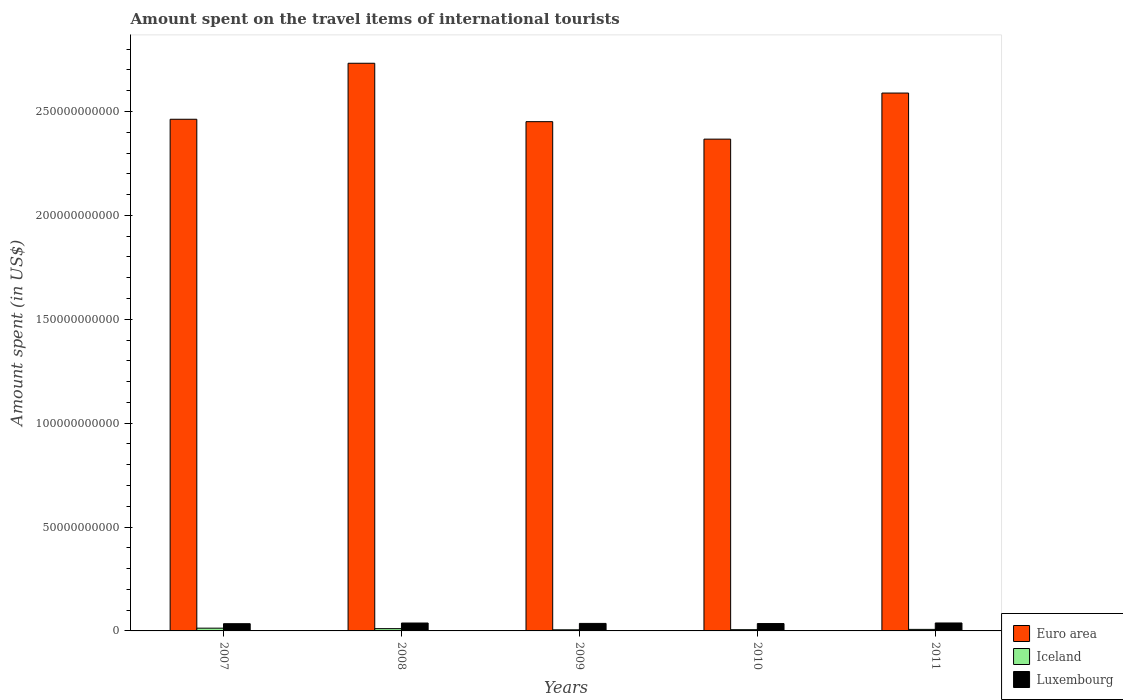How many groups of bars are there?
Your answer should be very brief. 5. Are the number of bars per tick equal to the number of legend labels?
Your answer should be compact. Yes. How many bars are there on the 1st tick from the left?
Your answer should be very brief. 3. How many bars are there on the 5th tick from the right?
Ensure brevity in your answer.  3. What is the label of the 5th group of bars from the left?
Your answer should be very brief. 2011. What is the amount spent on the travel items of international tourists in Iceland in 2008?
Your answer should be compact. 1.10e+09. Across all years, what is the maximum amount spent on the travel items of international tourists in Luxembourg?
Make the answer very short. 3.82e+09. Across all years, what is the minimum amount spent on the travel items of international tourists in Euro area?
Give a very brief answer. 2.37e+11. In which year was the amount spent on the travel items of international tourists in Luxembourg minimum?
Offer a terse response. 2007. What is the total amount spent on the travel items of international tourists in Luxembourg in the graph?
Make the answer very short. 1.83e+1. What is the difference between the amount spent on the travel items of international tourists in Iceland in 2009 and that in 2011?
Ensure brevity in your answer.  -2.06e+08. What is the difference between the amount spent on the travel items of international tourists in Euro area in 2007 and the amount spent on the travel items of international tourists in Iceland in 2009?
Make the answer very short. 2.46e+11. What is the average amount spent on the travel items of international tourists in Luxembourg per year?
Offer a very short reply. 3.65e+09. In the year 2010, what is the difference between the amount spent on the travel items of international tourists in Luxembourg and amount spent on the travel items of international tourists in Iceland?
Keep it short and to the point. 2.95e+09. What is the ratio of the amount spent on the travel items of international tourists in Iceland in 2008 to that in 2011?
Keep it short and to the point. 1.49. What is the difference between the highest and the second highest amount spent on the travel items of international tourists in Iceland?
Keep it short and to the point. 2.23e+08. What is the difference between the highest and the lowest amount spent on the travel items of international tourists in Iceland?
Provide a succinct answer. 7.92e+08. Is the sum of the amount spent on the travel items of international tourists in Iceland in 2007 and 2008 greater than the maximum amount spent on the travel items of international tourists in Luxembourg across all years?
Your answer should be compact. No. What does the 2nd bar from the right in 2010 represents?
Your response must be concise. Iceland. How many bars are there?
Provide a short and direct response. 15. Are all the bars in the graph horizontal?
Your answer should be very brief. No. What is the difference between two consecutive major ticks on the Y-axis?
Keep it short and to the point. 5.00e+1. Are the values on the major ticks of Y-axis written in scientific E-notation?
Keep it short and to the point. No. Where does the legend appear in the graph?
Give a very brief answer. Bottom right. How many legend labels are there?
Ensure brevity in your answer.  3. How are the legend labels stacked?
Make the answer very short. Vertical. What is the title of the graph?
Ensure brevity in your answer.  Amount spent on the travel items of international tourists. Does "Australia" appear as one of the legend labels in the graph?
Make the answer very short. No. What is the label or title of the X-axis?
Ensure brevity in your answer.  Years. What is the label or title of the Y-axis?
Keep it short and to the point. Amount spent (in US$). What is the Amount spent (in US$) in Euro area in 2007?
Offer a very short reply. 2.46e+11. What is the Amount spent (in US$) of Iceland in 2007?
Keep it short and to the point. 1.33e+09. What is the Amount spent (in US$) in Luxembourg in 2007?
Give a very brief answer. 3.48e+09. What is the Amount spent (in US$) of Euro area in 2008?
Ensure brevity in your answer.  2.73e+11. What is the Amount spent (in US$) of Iceland in 2008?
Ensure brevity in your answer.  1.10e+09. What is the Amount spent (in US$) of Luxembourg in 2008?
Your response must be concise. 3.80e+09. What is the Amount spent (in US$) in Euro area in 2009?
Offer a very short reply. 2.45e+11. What is the Amount spent (in US$) of Iceland in 2009?
Your answer should be compact. 5.34e+08. What is the Amount spent (in US$) of Luxembourg in 2009?
Make the answer very short. 3.61e+09. What is the Amount spent (in US$) in Euro area in 2010?
Your response must be concise. 2.37e+11. What is the Amount spent (in US$) in Iceland in 2010?
Your answer should be compact. 5.99e+08. What is the Amount spent (in US$) in Luxembourg in 2010?
Ensure brevity in your answer.  3.55e+09. What is the Amount spent (in US$) in Euro area in 2011?
Make the answer very short. 2.59e+11. What is the Amount spent (in US$) of Iceland in 2011?
Make the answer very short. 7.40e+08. What is the Amount spent (in US$) in Luxembourg in 2011?
Your answer should be compact. 3.82e+09. Across all years, what is the maximum Amount spent (in US$) in Euro area?
Provide a succinct answer. 2.73e+11. Across all years, what is the maximum Amount spent (in US$) of Iceland?
Keep it short and to the point. 1.33e+09. Across all years, what is the maximum Amount spent (in US$) of Luxembourg?
Your response must be concise. 3.82e+09. Across all years, what is the minimum Amount spent (in US$) of Euro area?
Make the answer very short. 2.37e+11. Across all years, what is the minimum Amount spent (in US$) of Iceland?
Your answer should be very brief. 5.34e+08. Across all years, what is the minimum Amount spent (in US$) in Luxembourg?
Offer a very short reply. 3.48e+09. What is the total Amount spent (in US$) of Euro area in the graph?
Offer a terse response. 1.26e+12. What is the total Amount spent (in US$) in Iceland in the graph?
Give a very brief answer. 4.30e+09. What is the total Amount spent (in US$) in Luxembourg in the graph?
Keep it short and to the point. 1.83e+1. What is the difference between the Amount spent (in US$) in Euro area in 2007 and that in 2008?
Make the answer very short. -2.70e+1. What is the difference between the Amount spent (in US$) in Iceland in 2007 and that in 2008?
Your answer should be compact. 2.23e+08. What is the difference between the Amount spent (in US$) in Luxembourg in 2007 and that in 2008?
Your answer should be very brief. -3.25e+08. What is the difference between the Amount spent (in US$) in Euro area in 2007 and that in 2009?
Offer a very short reply. 1.16e+09. What is the difference between the Amount spent (in US$) of Iceland in 2007 and that in 2009?
Offer a very short reply. 7.92e+08. What is the difference between the Amount spent (in US$) in Luxembourg in 2007 and that in 2009?
Make the answer very short. -1.36e+08. What is the difference between the Amount spent (in US$) of Euro area in 2007 and that in 2010?
Keep it short and to the point. 9.57e+09. What is the difference between the Amount spent (in US$) of Iceland in 2007 and that in 2010?
Your answer should be very brief. 7.27e+08. What is the difference between the Amount spent (in US$) of Luxembourg in 2007 and that in 2010?
Offer a very short reply. -7.30e+07. What is the difference between the Amount spent (in US$) in Euro area in 2007 and that in 2011?
Ensure brevity in your answer.  -1.26e+1. What is the difference between the Amount spent (in US$) in Iceland in 2007 and that in 2011?
Provide a succinct answer. 5.86e+08. What is the difference between the Amount spent (in US$) in Luxembourg in 2007 and that in 2011?
Keep it short and to the point. -3.46e+08. What is the difference between the Amount spent (in US$) in Euro area in 2008 and that in 2009?
Provide a succinct answer. 2.81e+1. What is the difference between the Amount spent (in US$) of Iceland in 2008 and that in 2009?
Provide a short and direct response. 5.69e+08. What is the difference between the Amount spent (in US$) of Luxembourg in 2008 and that in 2009?
Offer a terse response. 1.89e+08. What is the difference between the Amount spent (in US$) of Euro area in 2008 and that in 2010?
Ensure brevity in your answer.  3.65e+1. What is the difference between the Amount spent (in US$) in Iceland in 2008 and that in 2010?
Provide a short and direct response. 5.04e+08. What is the difference between the Amount spent (in US$) of Luxembourg in 2008 and that in 2010?
Make the answer very short. 2.52e+08. What is the difference between the Amount spent (in US$) of Euro area in 2008 and that in 2011?
Ensure brevity in your answer.  1.43e+1. What is the difference between the Amount spent (in US$) in Iceland in 2008 and that in 2011?
Offer a very short reply. 3.63e+08. What is the difference between the Amount spent (in US$) of Luxembourg in 2008 and that in 2011?
Offer a terse response. -2.10e+07. What is the difference between the Amount spent (in US$) in Euro area in 2009 and that in 2010?
Offer a terse response. 8.41e+09. What is the difference between the Amount spent (in US$) of Iceland in 2009 and that in 2010?
Provide a succinct answer. -6.50e+07. What is the difference between the Amount spent (in US$) in Luxembourg in 2009 and that in 2010?
Provide a short and direct response. 6.30e+07. What is the difference between the Amount spent (in US$) in Euro area in 2009 and that in 2011?
Provide a short and direct response. -1.38e+1. What is the difference between the Amount spent (in US$) in Iceland in 2009 and that in 2011?
Provide a succinct answer. -2.06e+08. What is the difference between the Amount spent (in US$) in Luxembourg in 2009 and that in 2011?
Provide a short and direct response. -2.10e+08. What is the difference between the Amount spent (in US$) in Euro area in 2010 and that in 2011?
Provide a short and direct response. -2.22e+1. What is the difference between the Amount spent (in US$) of Iceland in 2010 and that in 2011?
Your response must be concise. -1.41e+08. What is the difference between the Amount spent (in US$) of Luxembourg in 2010 and that in 2011?
Offer a very short reply. -2.73e+08. What is the difference between the Amount spent (in US$) of Euro area in 2007 and the Amount spent (in US$) of Iceland in 2008?
Keep it short and to the point. 2.45e+11. What is the difference between the Amount spent (in US$) of Euro area in 2007 and the Amount spent (in US$) of Luxembourg in 2008?
Keep it short and to the point. 2.42e+11. What is the difference between the Amount spent (in US$) of Iceland in 2007 and the Amount spent (in US$) of Luxembourg in 2008?
Your answer should be very brief. -2.48e+09. What is the difference between the Amount spent (in US$) of Euro area in 2007 and the Amount spent (in US$) of Iceland in 2009?
Your response must be concise. 2.46e+11. What is the difference between the Amount spent (in US$) in Euro area in 2007 and the Amount spent (in US$) in Luxembourg in 2009?
Provide a short and direct response. 2.43e+11. What is the difference between the Amount spent (in US$) in Iceland in 2007 and the Amount spent (in US$) in Luxembourg in 2009?
Ensure brevity in your answer.  -2.29e+09. What is the difference between the Amount spent (in US$) of Euro area in 2007 and the Amount spent (in US$) of Iceland in 2010?
Offer a very short reply. 2.46e+11. What is the difference between the Amount spent (in US$) of Euro area in 2007 and the Amount spent (in US$) of Luxembourg in 2010?
Provide a succinct answer. 2.43e+11. What is the difference between the Amount spent (in US$) of Iceland in 2007 and the Amount spent (in US$) of Luxembourg in 2010?
Ensure brevity in your answer.  -2.22e+09. What is the difference between the Amount spent (in US$) in Euro area in 2007 and the Amount spent (in US$) in Iceland in 2011?
Provide a succinct answer. 2.46e+11. What is the difference between the Amount spent (in US$) in Euro area in 2007 and the Amount spent (in US$) in Luxembourg in 2011?
Ensure brevity in your answer.  2.42e+11. What is the difference between the Amount spent (in US$) in Iceland in 2007 and the Amount spent (in US$) in Luxembourg in 2011?
Offer a very short reply. -2.50e+09. What is the difference between the Amount spent (in US$) of Euro area in 2008 and the Amount spent (in US$) of Iceland in 2009?
Your answer should be very brief. 2.73e+11. What is the difference between the Amount spent (in US$) in Euro area in 2008 and the Amount spent (in US$) in Luxembourg in 2009?
Your response must be concise. 2.70e+11. What is the difference between the Amount spent (in US$) of Iceland in 2008 and the Amount spent (in US$) of Luxembourg in 2009?
Provide a succinct answer. -2.51e+09. What is the difference between the Amount spent (in US$) of Euro area in 2008 and the Amount spent (in US$) of Iceland in 2010?
Provide a succinct answer. 2.73e+11. What is the difference between the Amount spent (in US$) in Euro area in 2008 and the Amount spent (in US$) in Luxembourg in 2010?
Make the answer very short. 2.70e+11. What is the difference between the Amount spent (in US$) of Iceland in 2008 and the Amount spent (in US$) of Luxembourg in 2010?
Give a very brief answer. -2.45e+09. What is the difference between the Amount spent (in US$) in Euro area in 2008 and the Amount spent (in US$) in Iceland in 2011?
Offer a very short reply. 2.72e+11. What is the difference between the Amount spent (in US$) of Euro area in 2008 and the Amount spent (in US$) of Luxembourg in 2011?
Make the answer very short. 2.69e+11. What is the difference between the Amount spent (in US$) in Iceland in 2008 and the Amount spent (in US$) in Luxembourg in 2011?
Offer a terse response. -2.72e+09. What is the difference between the Amount spent (in US$) of Euro area in 2009 and the Amount spent (in US$) of Iceland in 2010?
Offer a very short reply. 2.45e+11. What is the difference between the Amount spent (in US$) in Euro area in 2009 and the Amount spent (in US$) in Luxembourg in 2010?
Offer a terse response. 2.42e+11. What is the difference between the Amount spent (in US$) in Iceland in 2009 and the Amount spent (in US$) in Luxembourg in 2010?
Provide a short and direct response. -3.02e+09. What is the difference between the Amount spent (in US$) in Euro area in 2009 and the Amount spent (in US$) in Iceland in 2011?
Provide a succinct answer. 2.44e+11. What is the difference between the Amount spent (in US$) in Euro area in 2009 and the Amount spent (in US$) in Luxembourg in 2011?
Ensure brevity in your answer.  2.41e+11. What is the difference between the Amount spent (in US$) of Iceland in 2009 and the Amount spent (in US$) of Luxembourg in 2011?
Your answer should be compact. -3.29e+09. What is the difference between the Amount spent (in US$) in Euro area in 2010 and the Amount spent (in US$) in Iceland in 2011?
Keep it short and to the point. 2.36e+11. What is the difference between the Amount spent (in US$) of Euro area in 2010 and the Amount spent (in US$) of Luxembourg in 2011?
Ensure brevity in your answer.  2.33e+11. What is the difference between the Amount spent (in US$) in Iceland in 2010 and the Amount spent (in US$) in Luxembourg in 2011?
Offer a very short reply. -3.22e+09. What is the average Amount spent (in US$) in Euro area per year?
Keep it short and to the point. 2.52e+11. What is the average Amount spent (in US$) in Iceland per year?
Offer a terse response. 8.60e+08. What is the average Amount spent (in US$) in Luxembourg per year?
Offer a very short reply. 3.65e+09. In the year 2007, what is the difference between the Amount spent (in US$) in Euro area and Amount spent (in US$) in Iceland?
Provide a short and direct response. 2.45e+11. In the year 2007, what is the difference between the Amount spent (in US$) in Euro area and Amount spent (in US$) in Luxembourg?
Your answer should be very brief. 2.43e+11. In the year 2007, what is the difference between the Amount spent (in US$) in Iceland and Amount spent (in US$) in Luxembourg?
Ensure brevity in your answer.  -2.15e+09. In the year 2008, what is the difference between the Amount spent (in US$) in Euro area and Amount spent (in US$) in Iceland?
Provide a short and direct response. 2.72e+11. In the year 2008, what is the difference between the Amount spent (in US$) of Euro area and Amount spent (in US$) of Luxembourg?
Ensure brevity in your answer.  2.69e+11. In the year 2008, what is the difference between the Amount spent (in US$) in Iceland and Amount spent (in US$) in Luxembourg?
Your answer should be compact. -2.70e+09. In the year 2009, what is the difference between the Amount spent (in US$) of Euro area and Amount spent (in US$) of Iceland?
Your answer should be very brief. 2.45e+11. In the year 2009, what is the difference between the Amount spent (in US$) of Euro area and Amount spent (in US$) of Luxembourg?
Make the answer very short. 2.41e+11. In the year 2009, what is the difference between the Amount spent (in US$) in Iceland and Amount spent (in US$) in Luxembourg?
Provide a short and direct response. -3.08e+09. In the year 2010, what is the difference between the Amount spent (in US$) in Euro area and Amount spent (in US$) in Iceland?
Give a very brief answer. 2.36e+11. In the year 2010, what is the difference between the Amount spent (in US$) of Euro area and Amount spent (in US$) of Luxembourg?
Your response must be concise. 2.33e+11. In the year 2010, what is the difference between the Amount spent (in US$) of Iceland and Amount spent (in US$) of Luxembourg?
Make the answer very short. -2.95e+09. In the year 2011, what is the difference between the Amount spent (in US$) of Euro area and Amount spent (in US$) of Iceland?
Give a very brief answer. 2.58e+11. In the year 2011, what is the difference between the Amount spent (in US$) of Euro area and Amount spent (in US$) of Luxembourg?
Make the answer very short. 2.55e+11. In the year 2011, what is the difference between the Amount spent (in US$) in Iceland and Amount spent (in US$) in Luxembourg?
Provide a succinct answer. -3.08e+09. What is the ratio of the Amount spent (in US$) of Euro area in 2007 to that in 2008?
Your response must be concise. 0.9. What is the ratio of the Amount spent (in US$) of Iceland in 2007 to that in 2008?
Give a very brief answer. 1.2. What is the ratio of the Amount spent (in US$) in Luxembourg in 2007 to that in 2008?
Keep it short and to the point. 0.91. What is the ratio of the Amount spent (in US$) in Euro area in 2007 to that in 2009?
Offer a terse response. 1. What is the ratio of the Amount spent (in US$) in Iceland in 2007 to that in 2009?
Provide a succinct answer. 2.48. What is the ratio of the Amount spent (in US$) of Luxembourg in 2007 to that in 2009?
Your answer should be compact. 0.96. What is the ratio of the Amount spent (in US$) of Euro area in 2007 to that in 2010?
Your answer should be very brief. 1.04. What is the ratio of the Amount spent (in US$) in Iceland in 2007 to that in 2010?
Your response must be concise. 2.21. What is the ratio of the Amount spent (in US$) of Luxembourg in 2007 to that in 2010?
Make the answer very short. 0.98. What is the ratio of the Amount spent (in US$) of Euro area in 2007 to that in 2011?
Offer a terse response. 0.95. What is the ratio of the Amount spent (in US$) in Iceland in 2007 to that in 2011?
Your response must be concise. 1.79. What is the ratio of the Amount spent (in US$) in Luxembourg in 2007 to that in 2011?
Your response must be concise. 0.91. What is the ratio of the Amount spent (in US$) in Euro area in 2008 to that in 2009?
Keep it short and to the point. 1.11. What is the ratio of the Amount spent (in US$) of Iceland in 2008 to that in 2009?
Offer a terse response. 2.07. What is the ratio of the Amount spent (in US$) of Luxembourg in 2008 to that in 2009?
Your response must be concise. 1.05. What is the ratio of the Amount spent (in US$) in Euro area in 2008 to that in 2010?
Your answer should be very brief. 1.15. What is the ratio of the Amount spent (in US$) in Iceland in 2008 to that in 2010?
Your answer should be very brief. 1.84. What is the ratio of the Amount spent (in US$) in Luxembourg in 2008 to that in 2010?
Offer a very short reply. 1.07. What is the ratio of the Amount spent (in US$) in Euro area in 2008 to that in 2011?
Your answer should be compact. 1.06. What is the ratio of the Amount spent (in US$) in Iceland in 2008 to that in 2011?
Provide a succinct answer. 1.49. What is the ratio of the Amount spent (in US$) in Luxembourg in 2008 to that in 2011?
Your answer should be compact. 0.99. What is the ratio of the Amount spent (in US$) of Euro area in 2009 to that in 2010?
Your answer should be very brief. 1.04. What is the ratio of the Amount spent (in US$) in Iceland in 2009 to that in 2010?
Make the answer very short. 0.89. What is the ratio of the Amount spent (in US$) of Luxembourg in 2009 to that in 2010?
Your answer should be compact. 1.02. What is the ratio of the Amount spent (in US$) in Euro area in 2009 to that in 2011?
Give a very brief answer. 0.95. What is the ratio of the Amount spent (in US$) of Iceland in 2009 to that in 2011?
Provide a succinct answer. 0.72. What is the ratio of the Amount spent (in US$) of Luxembourg in 2009 to that in 2011?
Make the answer very short. 0.95. What is the ratio of the Amount spent (in US$) of Euro area in 2010 to that in 2011?
Provide a succinct answer. 0.91. What is the ratio of the Amount spent (in US$) of Iceland in 2010 to that in 2011?
Ensure brevity in your answer.  0.81. What is the difference between the highest and the second highest Amount spent (in US$) of Euro area?
Ensure brevity in your answer.  1.43e+1. What is the difference between the highest and the second highest Amount spent (in US$) in Iceland?
Ensure brevity in your answer.  2.23e+08. What is the difference between the highest and the second highest Amount spent (in US$) of Luxembourg?
Ensure brevity in your answer.  2.10e+07. What is the difference between the highest and the lowest Amount spent (in US$) in Euro area?
Give a very brief answer. 3.65e+1. What is the difference between the highest and the lowest Amount spent (in US$) in Iceland?
Ensure brevity in your answer.  7.92e+08. What is the difference between the highest and the lowest Amount spent (in US$) of Luxembourg?
Your answer should be very brief. 3.46e+08. 